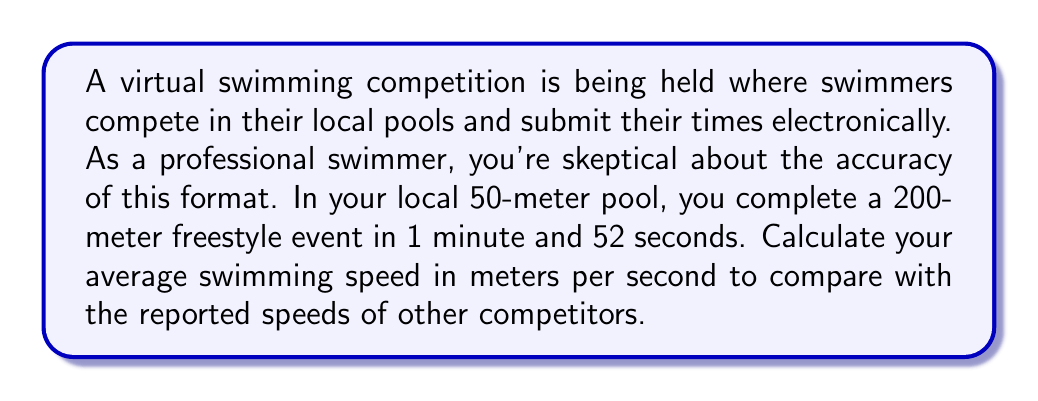Show me your answer to this math problem. To calculate the average swimming speed, we need to use the formula:

$$\text{Speed} = \frac{\text{Distance}}{\text{Time}}$$

Let's break down the given information:
1. Distance: 200 meters
2. Time: 1 minute and 52 seconds

First, we need to convert the time to seconds:
1 minute = 60 seconds
52 seconds
Total time = $60 + 52 = 112$ seconds

Now, we can plug these values into our formula:

$$\text{Speed} = \frac{200 \text{ meters}}{112 \text{ seconds}}$$

To simplify this fraction:

$$\text{Speed} = \frac{25}{14} \text{ meters per second}$$

To get a decimal approximation:

$$\text{Speed} \approx 1.7857 \text{ meters per second}$$

This speed can be used to compare with other competitors' reported speeds in the virtual competition.
Answer: $\frac{25}{14}$ m/s or approximately 1.79 m/s 